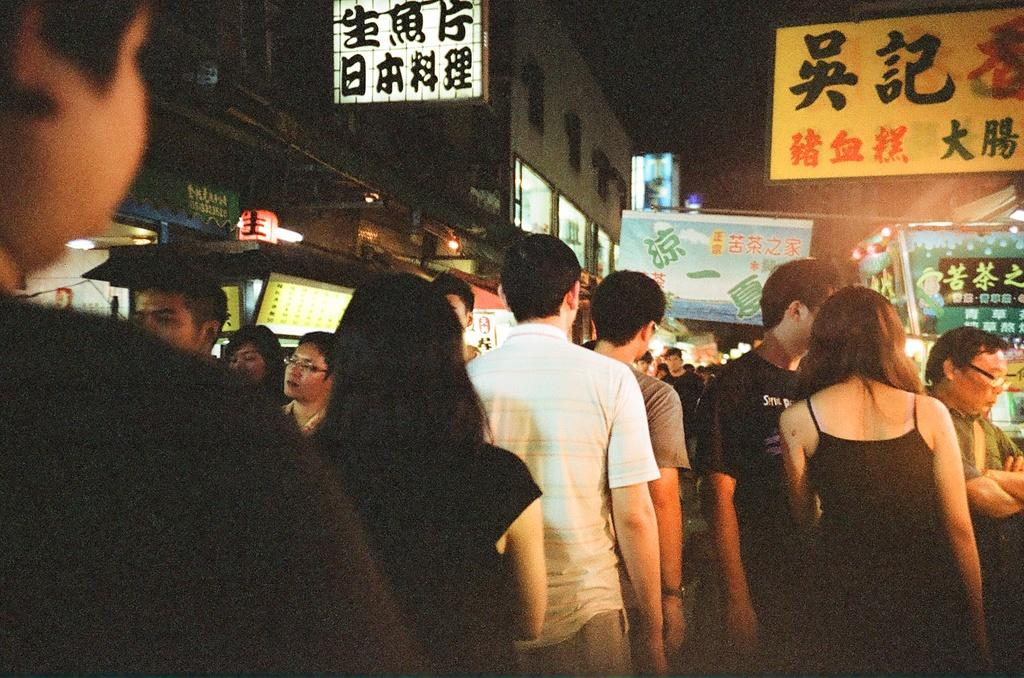What is the main subject of the picture? The main subject of the picture is people. Can you describe the people in the picture? There are men and women in the picture. What can be seen in the background of the picture? There are buildings in the background of the picture. What type of guide is being used by the people in the picture? There is no guide visible in the image. 